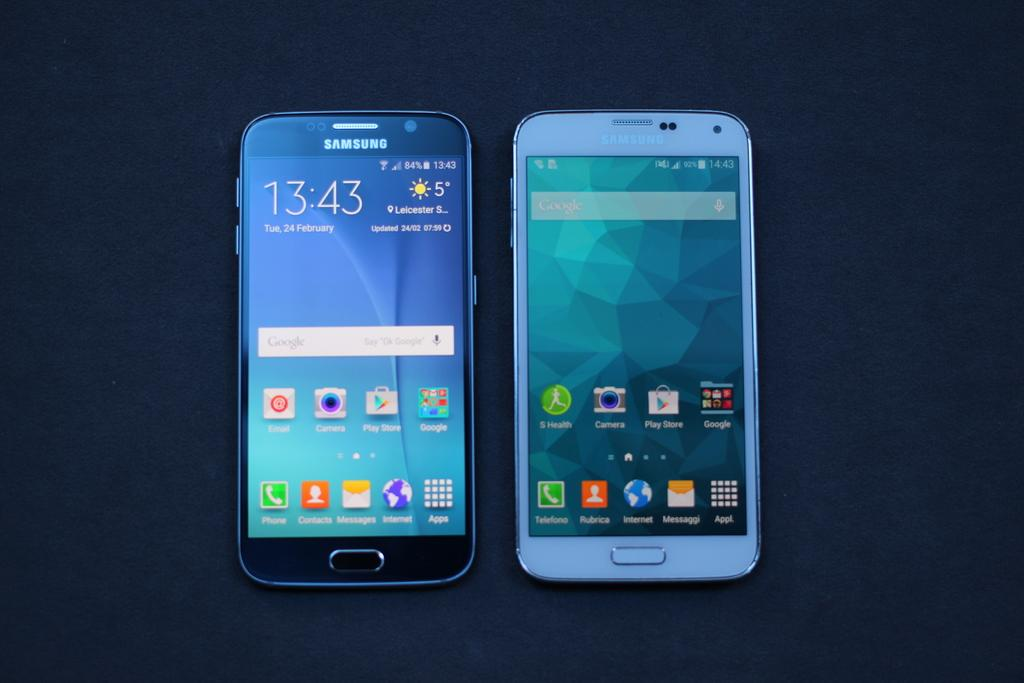Provide a one-sentence caption for the provided image. two black and white SAMSUNG phones open to home screens. 